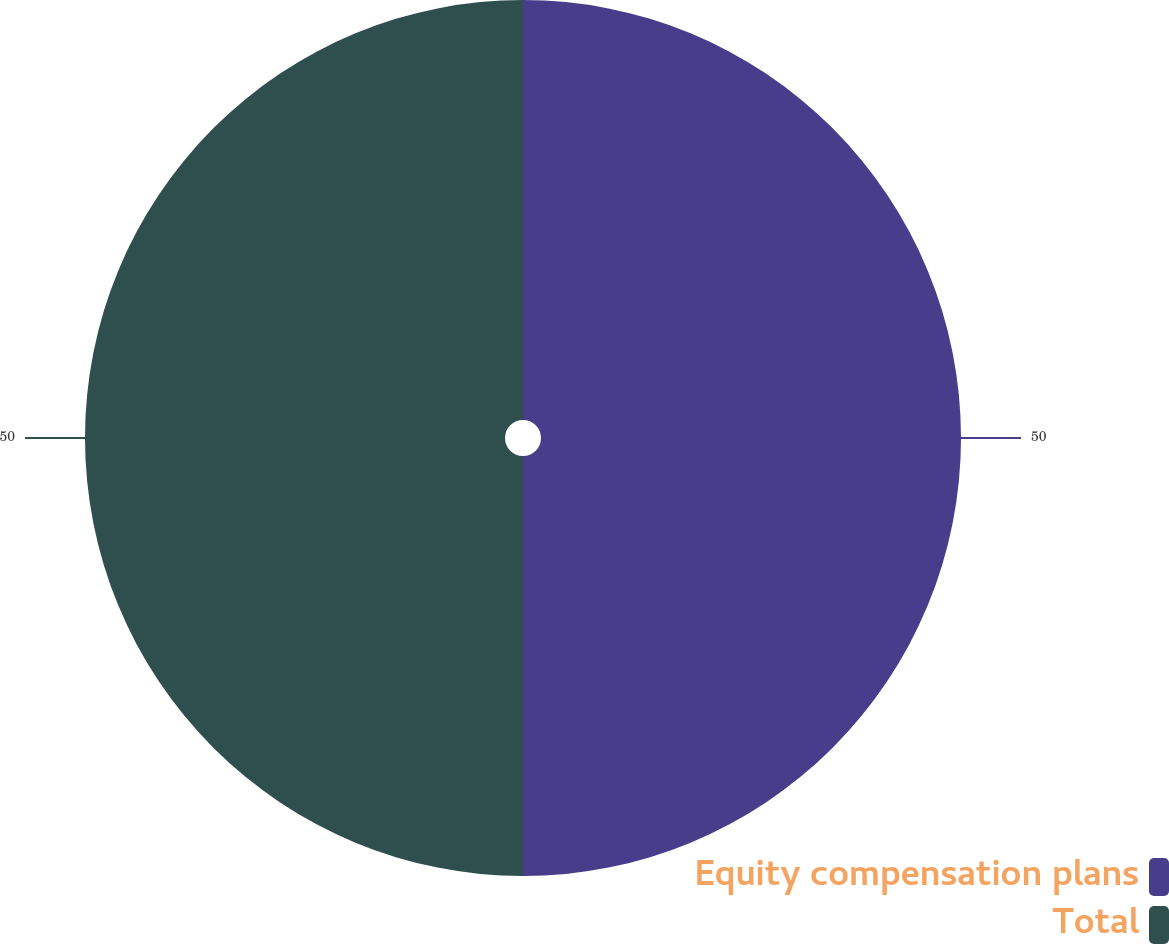Convert chart to OTSL. <chart><loc_0><loc_0><loc_500><loc_500><pie_chart><fcel>Equity compensation plans<fcel>Total<nl><fcel>50.0%<fcel>50.0%<nl></chart> 